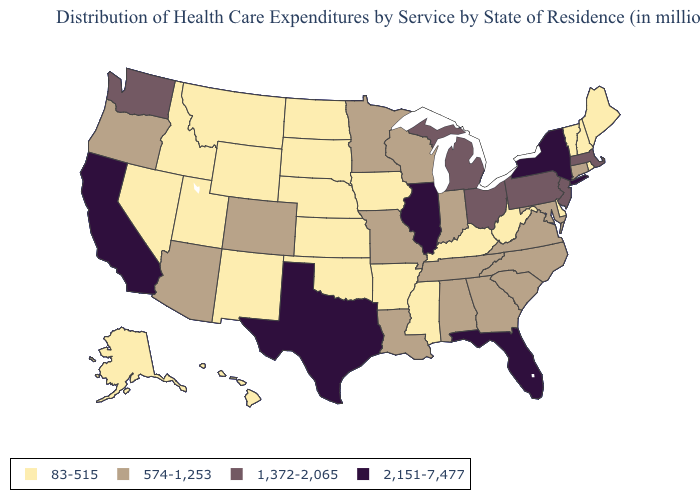What is the highest value in the South ?
Give a very brief answer. 2,151-7,477. Does the first symbol in the legend represent the smallest category?
Write a very short answer. Yes. Which states have the lowest value in the MidWest?
Be succinct. Iowa, Kansas, Nebraska, North Dakota, South Dakota. Name the states that have a value in the range 1,372-2,065?
Answer briefly. Massachusetts, Michigan, New Jersey, Ohio, Pennsylvania, Washington. Among the states that border New Jersey , does Pennsylvania have the highest value?
Concise answer only. No. Name the states that have a value in the range 2,151-7,477?
Quick response, please. California, Florida, Illinois, New York, Texas. Among the states that border Indiana , which have the lowest value?
Answer briefly. Kentucky. Does New York have the same value as Illinois?
Answer briefly. Yes. What is the highest value in the Northeast ?
Concise answer only. 2,151-7,477. Name the states that have a value in the range 1,372-2,065?
Write a very short answer. Massachusetts, Michigan, New Jersey, Ohio, Pennsylvania, Washington. What is the value of Georgia?
Answer briefly. 574-1,253. What is the value of Wisconsin?
Concise answer only. 574-1,253. Name the states that have a value in the range 1,372-2,065?
Write a very short answer. Massachusetts, Michigan, New Jersey, Ohio, Pennsylvania, Washington. Does Pennsylvania have the lowest value in the Northeast?
Give a very brief answer. No. Among the states that border Illinois , which have the highest value?
Short answer required. Indiana, Missouri, Wisconsin. 